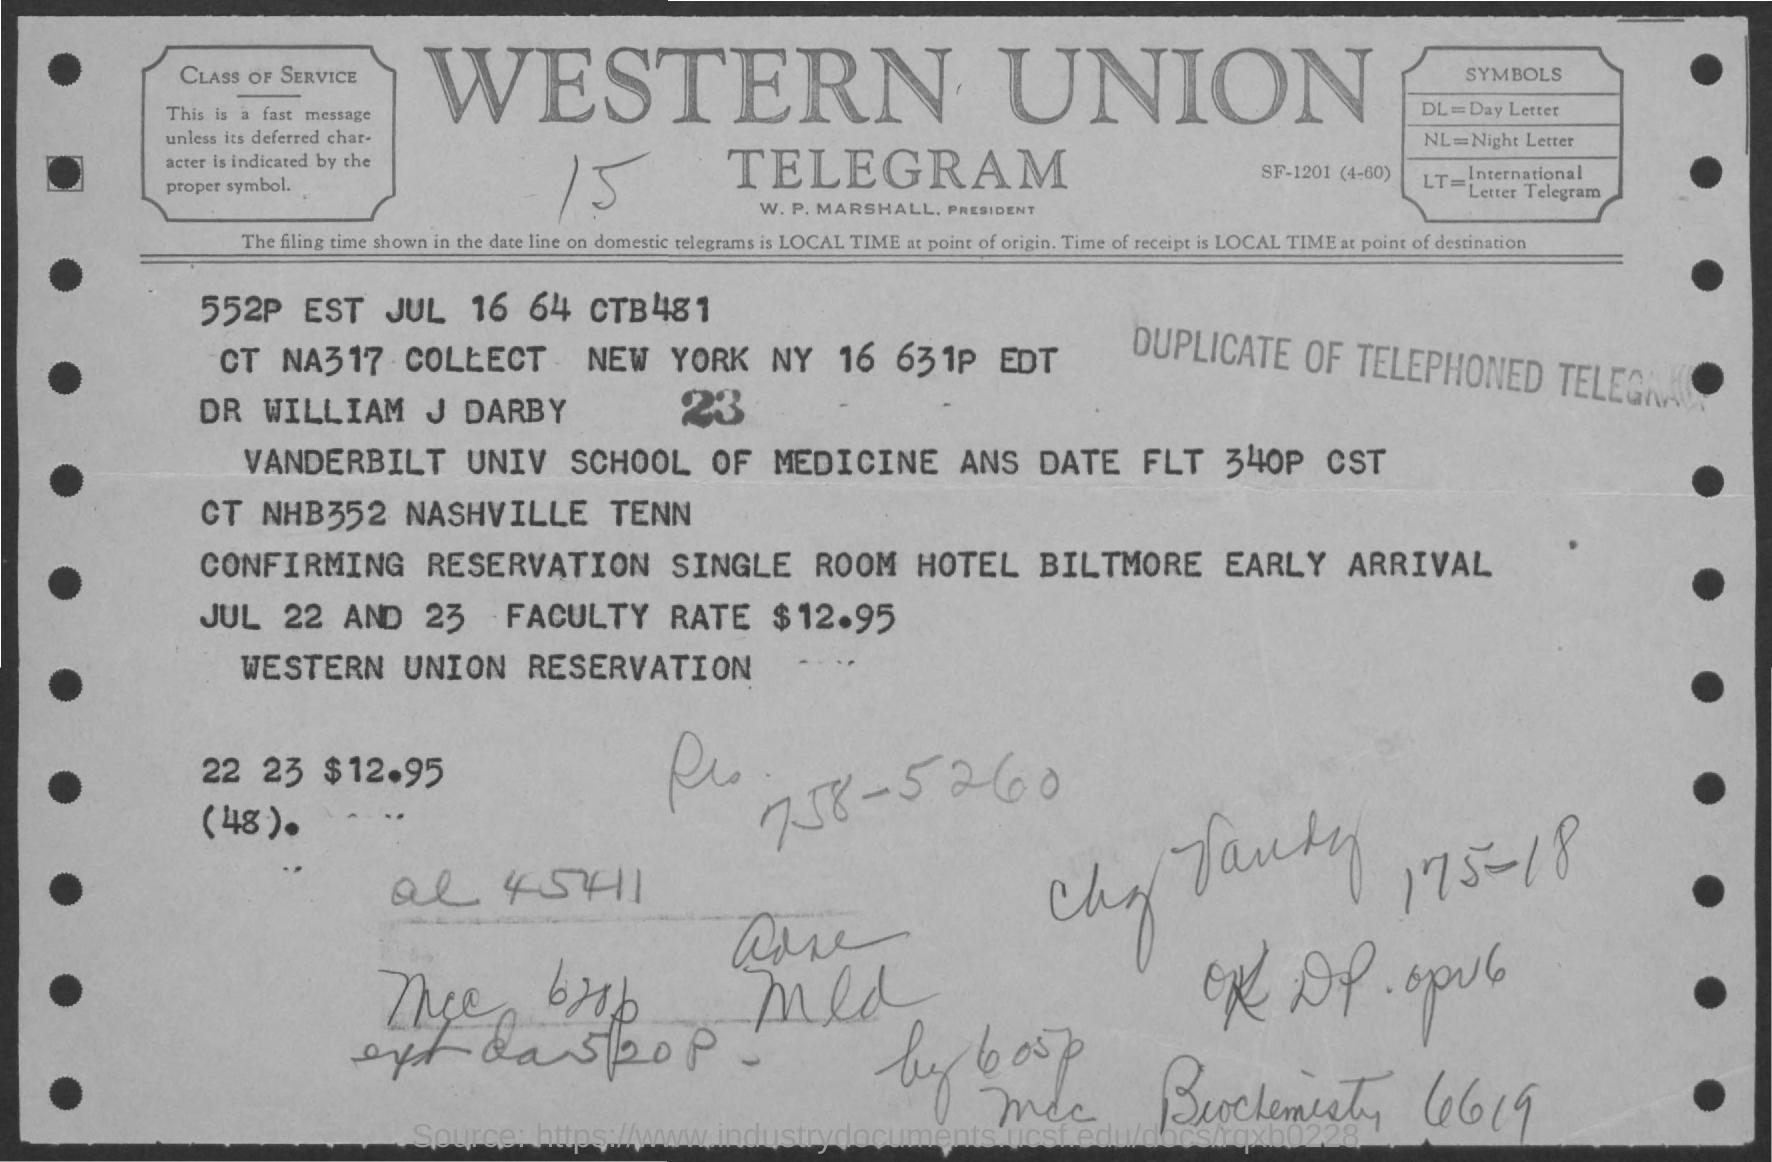Draw attention to some important aspects in this diagram. The symbol for Day Letter is dl. 